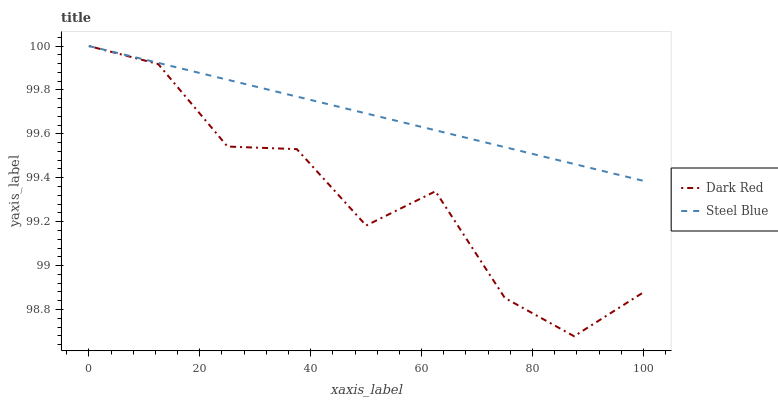Does Dark Red have the minimum area under the curve?
Answer yes or no. Yes. Does Steel Blue have the maximum area under the curve?
Answer yes or no. Yes. Does Steel Blue have the minimum area under the curve?
Answer yes or no. No. Is Steel Blue the smoothest?
Answer yes or no. Yes. Is Dark Red the roughest?
Answer yes or no. Yes. Is Steel Blue the roughest?
Answer yes or no. No. Does Dark Red have the lowest value?
Answer yes or no. Yes. Does Steel Blue have the lowest value?
Answer yes or no. No. Does Steel Blue have the highest value?
Answer yes or no. Yes. Does Steel Blue intersect Dark Red?
Answer yes or no. Yes. Is Steel Blue less than Dark Red?
Answer yes or no. No. Is Steel Blue greater than Dark Red?
Answer yes or no. No. 